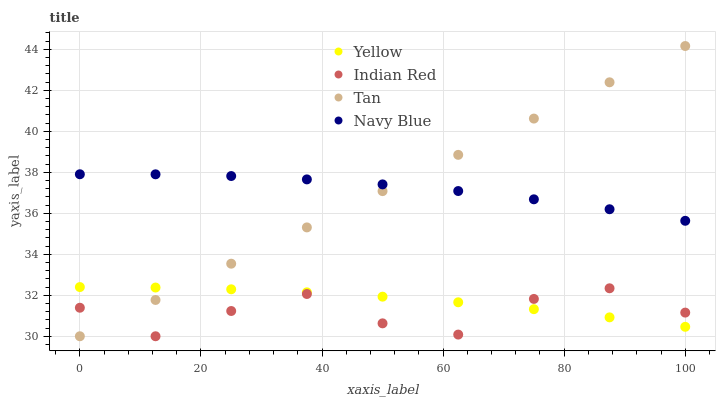Does Indian Red have the minimum area under the curve?
Answer yes or no. Yes. Does Navy Blue have the maximum area under the curve?
Answer yes or no. Yes. Does Tan have the minimum area under the curve?
Answer yes or no. No. Does Tan have the maximum area under the curve?
Answer yes or no. No. Is Tan the smoothest?
Answer yes or no. Yes. Is Indian Red the roughest?
Answer yes or no. Yes. Is Indian Red the smoothest?
Answer yes or no. No. Is Tan the roughest?
Answer yes or no. No. Does Tan have the lowest value?
Answer yes or no. Yes. Does Yellow have the lowest value?
Answer yes or no. No. Does Tan have the highest value?
Answer yes or no. Yes. Does Indian Red have the highest value?
Answer yes or no. No. Is Indian Red less than Navy Blue?
Answer yes or no. Yes. Is Navy Blue greater than Indian Red?
Answer yes or no. Yes. Does Tan intersect Navy Blue?
Answer yes or no. Yes. Is Tan less than Navy Blue?
Answer yes or no. No. Is Tan greater than Navy Blue?
Answer yes or no. No. Does Indian Red intersect Navy Blue?
Answer yes or no. No. 